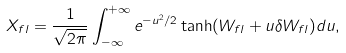<formula> <loc_0><loc_0><loc_500><loc_500>X _ { { f } l } = \frac { 1 } { \sqrt { 2 \pi } } \int _ { - \infty } ^ { + \infty } e ^ { - { u ^ { 2 } / 2 } } \tanh ( W _ { { f } l } + u \delta W _ { { f } l } ) d u ,</formula> 